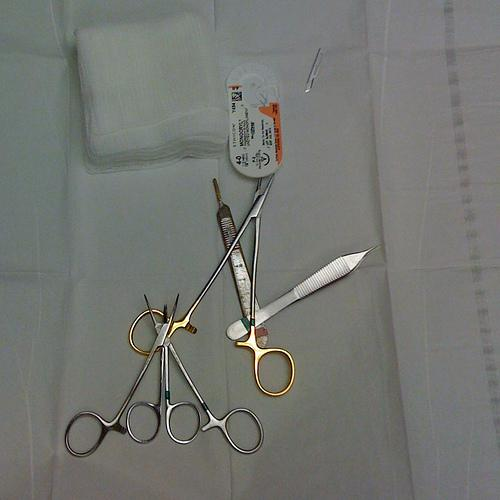Question: what color is the handle of the scissors on top of the tweezers?
Choices:
A. Orange.
B. Gold.
C. Red.
D. Blue.
Answer with the letter. Answer: B Question: how many scissors are there?
Choices:
A. Three.
B. Four.
C. Five.
D. Six.
Answer with the letter. Answer: A Question: when was the picture taken?
Choices:
A. Morning.
B. Evening.
C. Afternoon.
D. Night.
Answer with the letter. Answer: B 